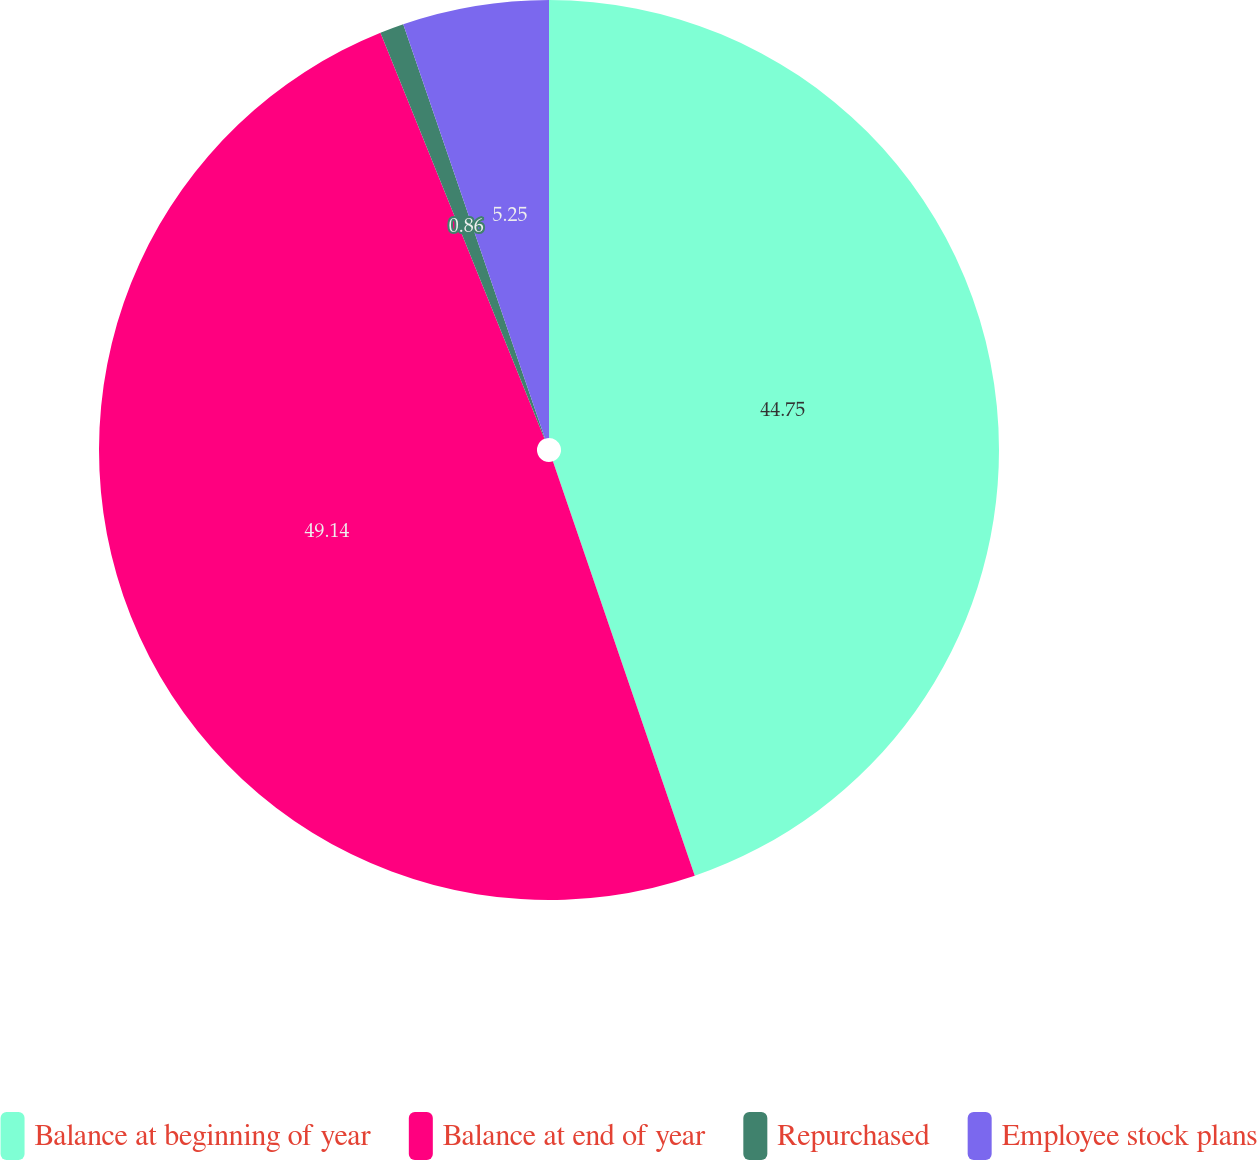<chart> <loc_0><loc_0><loc_500><loc_500><pie_chart><fcel>Balance at beginning of year<fcel>Balance at end of year<fcel>Repurchased<fcel>Employee stock plans<nl><fcel>44.75%<fcel>49.14%<fcel>0.86%<fcel>5.25%<nl></chart> 